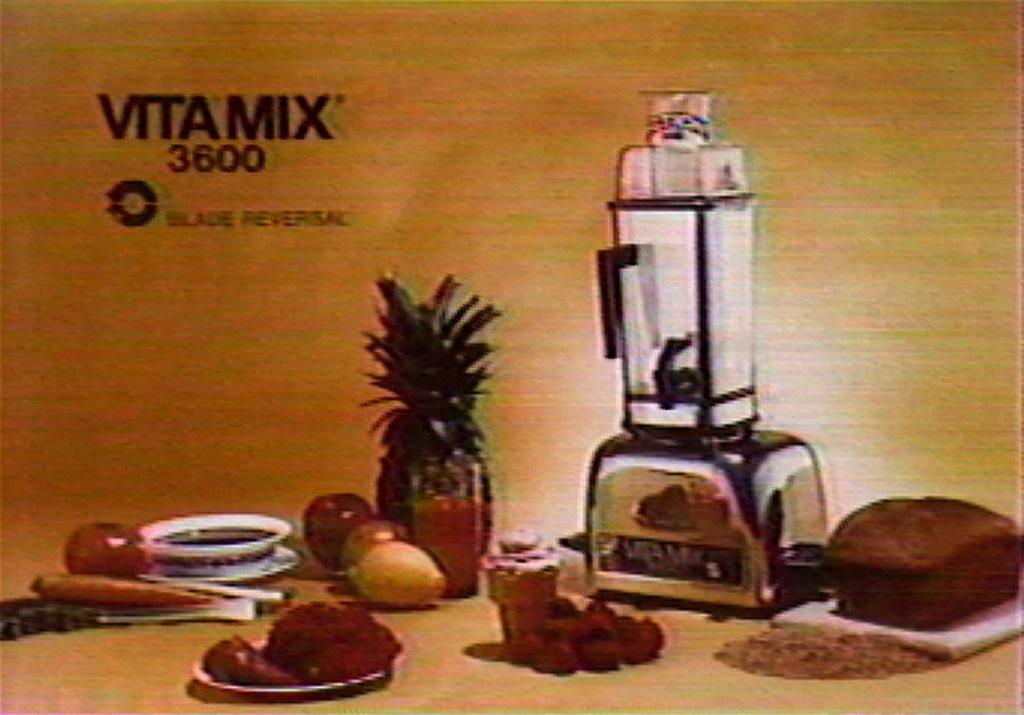<image>
Give a short and clear explanation of the subsequent image. A foodmixer surrounded by food with the word Vitamix 3600 in the top left 